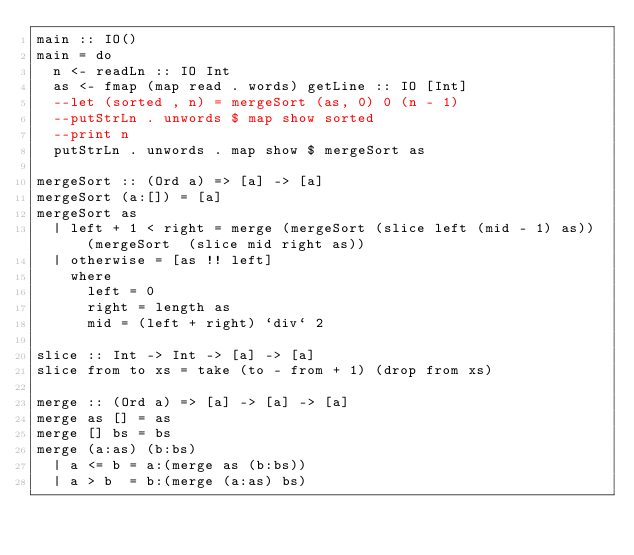Convert code to text. <code><loc_0><loc_0><loc_500><loc_500><_Haskell_>main :: IO()
main = do
  n <- readLn :: IO Int
  as <- fmap (map read . words) getLine :: IO [Int]
  --let (sorted , n) = mergeSort (as, 0) 0 (n - 1)
  --putStrLn . unwords $ map show sorted
  --print n
  putStrLn . unwords . map show $ mergeSort as

mergeSort :: (Ord a) => [a] -> [a]
mergeSort (a:[]) = [a]
mergeSort as
  | left + 1 < right = merge (mergeSort (slice left (mid - 1) as)) (mergeSort  (slice mid right as))
  | otherwise = [as !! left]
    where
      left = 0
      right = length as
      mid = (left + right) `div` 2

slice :: Int -> Int -> [a] -> [a]
slice from to xs = take (to - from + 1) (drop from xs)

merge :: (Ord a) => [a] -> [a] -> [a]
merge as [] = as
merge [] bs = bs
merge (a:as) (b:bs)
  | a <= b = a:(merge as (b:bs))
  | a > b  = b:(merge (a:as) bs)

</code> 